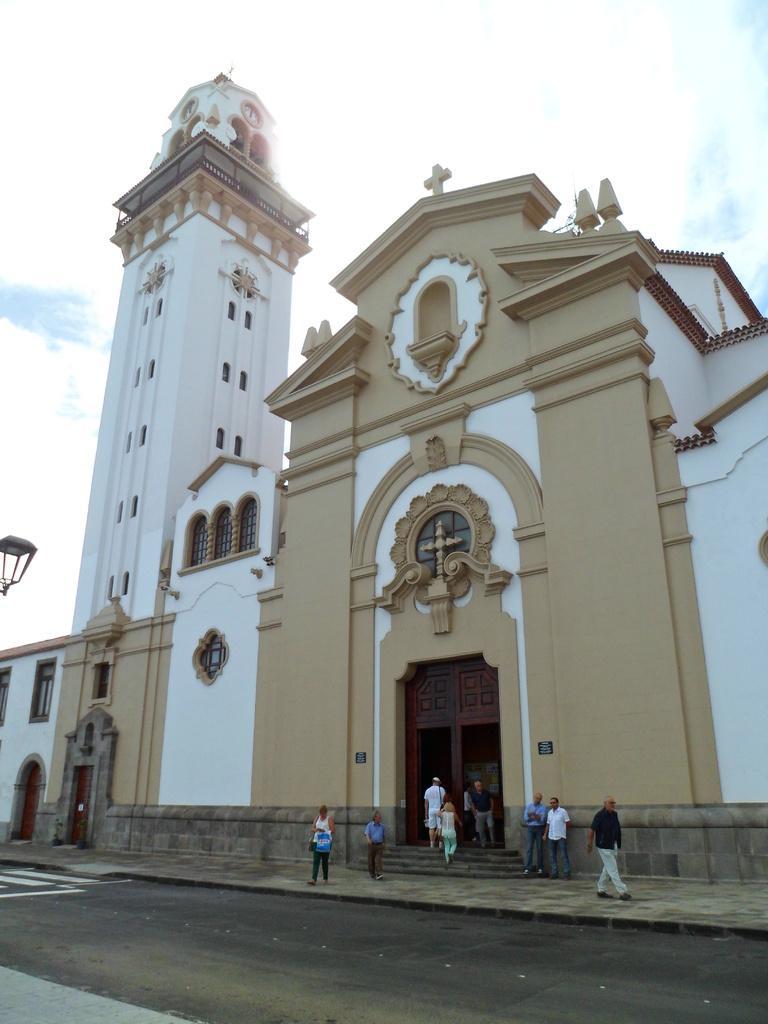Describe this image in one or two sentences. In the picture I can see people walking on the sidewalk and on the the steps. Here we can see Church building, I can see road and the cloudy sky in the background. 